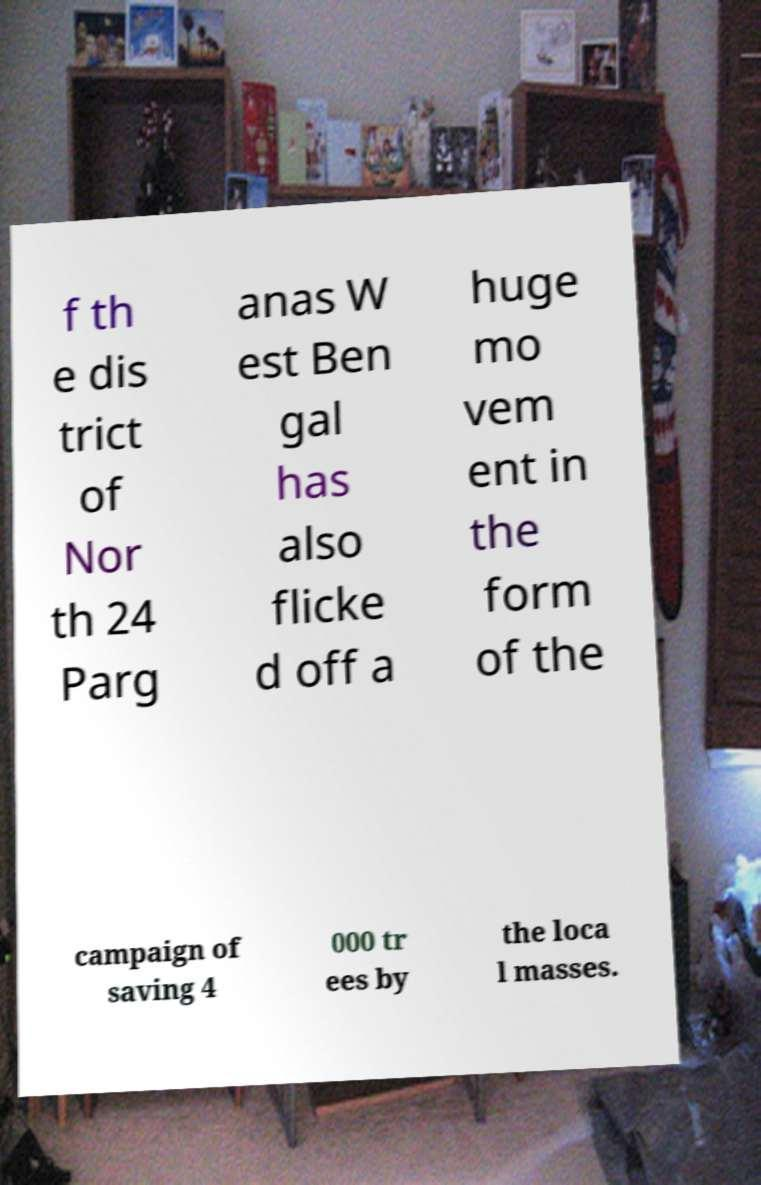I need the written content from this picture converted into text. Can you do that? f th e dis trict of Nor th 24 Parg anas W est Ben gal has also flicke d off a huge mo vem ent in the form of the campaign of saving 4 000 tr ees by the loca l masses. 